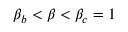<formula> <loc_0><loc_0><loc_500><loc_500>\beta _ { b } < \beta < \beta _ { c } = 1</formula> 